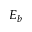<formula> <loc_0><loc_0><loc_500><loc_500>E _ { b }</formula> 